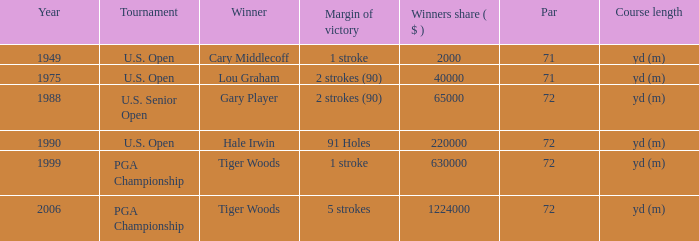When gary player is the winner what is the lowest winners share in dollars? 65000.0. Can you parse all the data within this table? {'header': ['Year', 'Tournament', 'Winner', 'Margin of victory', 'Winners share ( $ )', 'Par', 'Course length'], 'rows': [['1949', 'U.S. Open', 'Cary Middlecoff', '1 stroke', '2000', '71', 'yd (m)'], ['1975', 'U.S. Open', 'Lou Graham', '2 strokes (90)', '40000', '71', 'yd (m)'], ['1988', 'U.S. Senior Open', 'Gary Player', '2 strokes (90)', '65000', '72', 'yd (m)'], ['1990', 'U.S. Open', 'Hale Irwin', '91 Holes', '220000', '72', 'yd (m)'], ['1999', 'PGA Championship', 'Tiger Woods', '1 stroke', '630000', '72', 'yd (m)'], ['2006', 'PGA Championship', 'Tiger Woods', '5 strokes', '1224000', '72', 'yd (m)']]} 